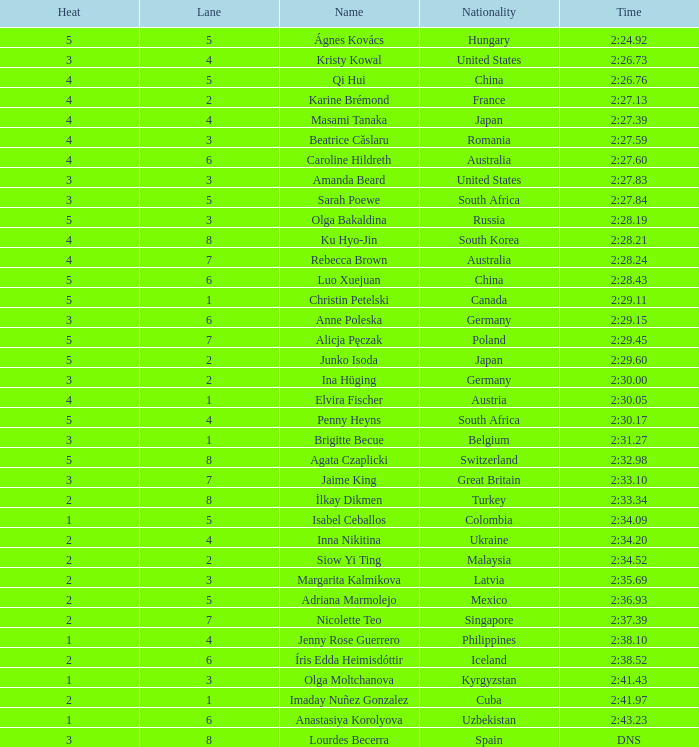What is the term that experienced 4 heat sessions and a track higher than 7? Ku Hyo-Jin. 